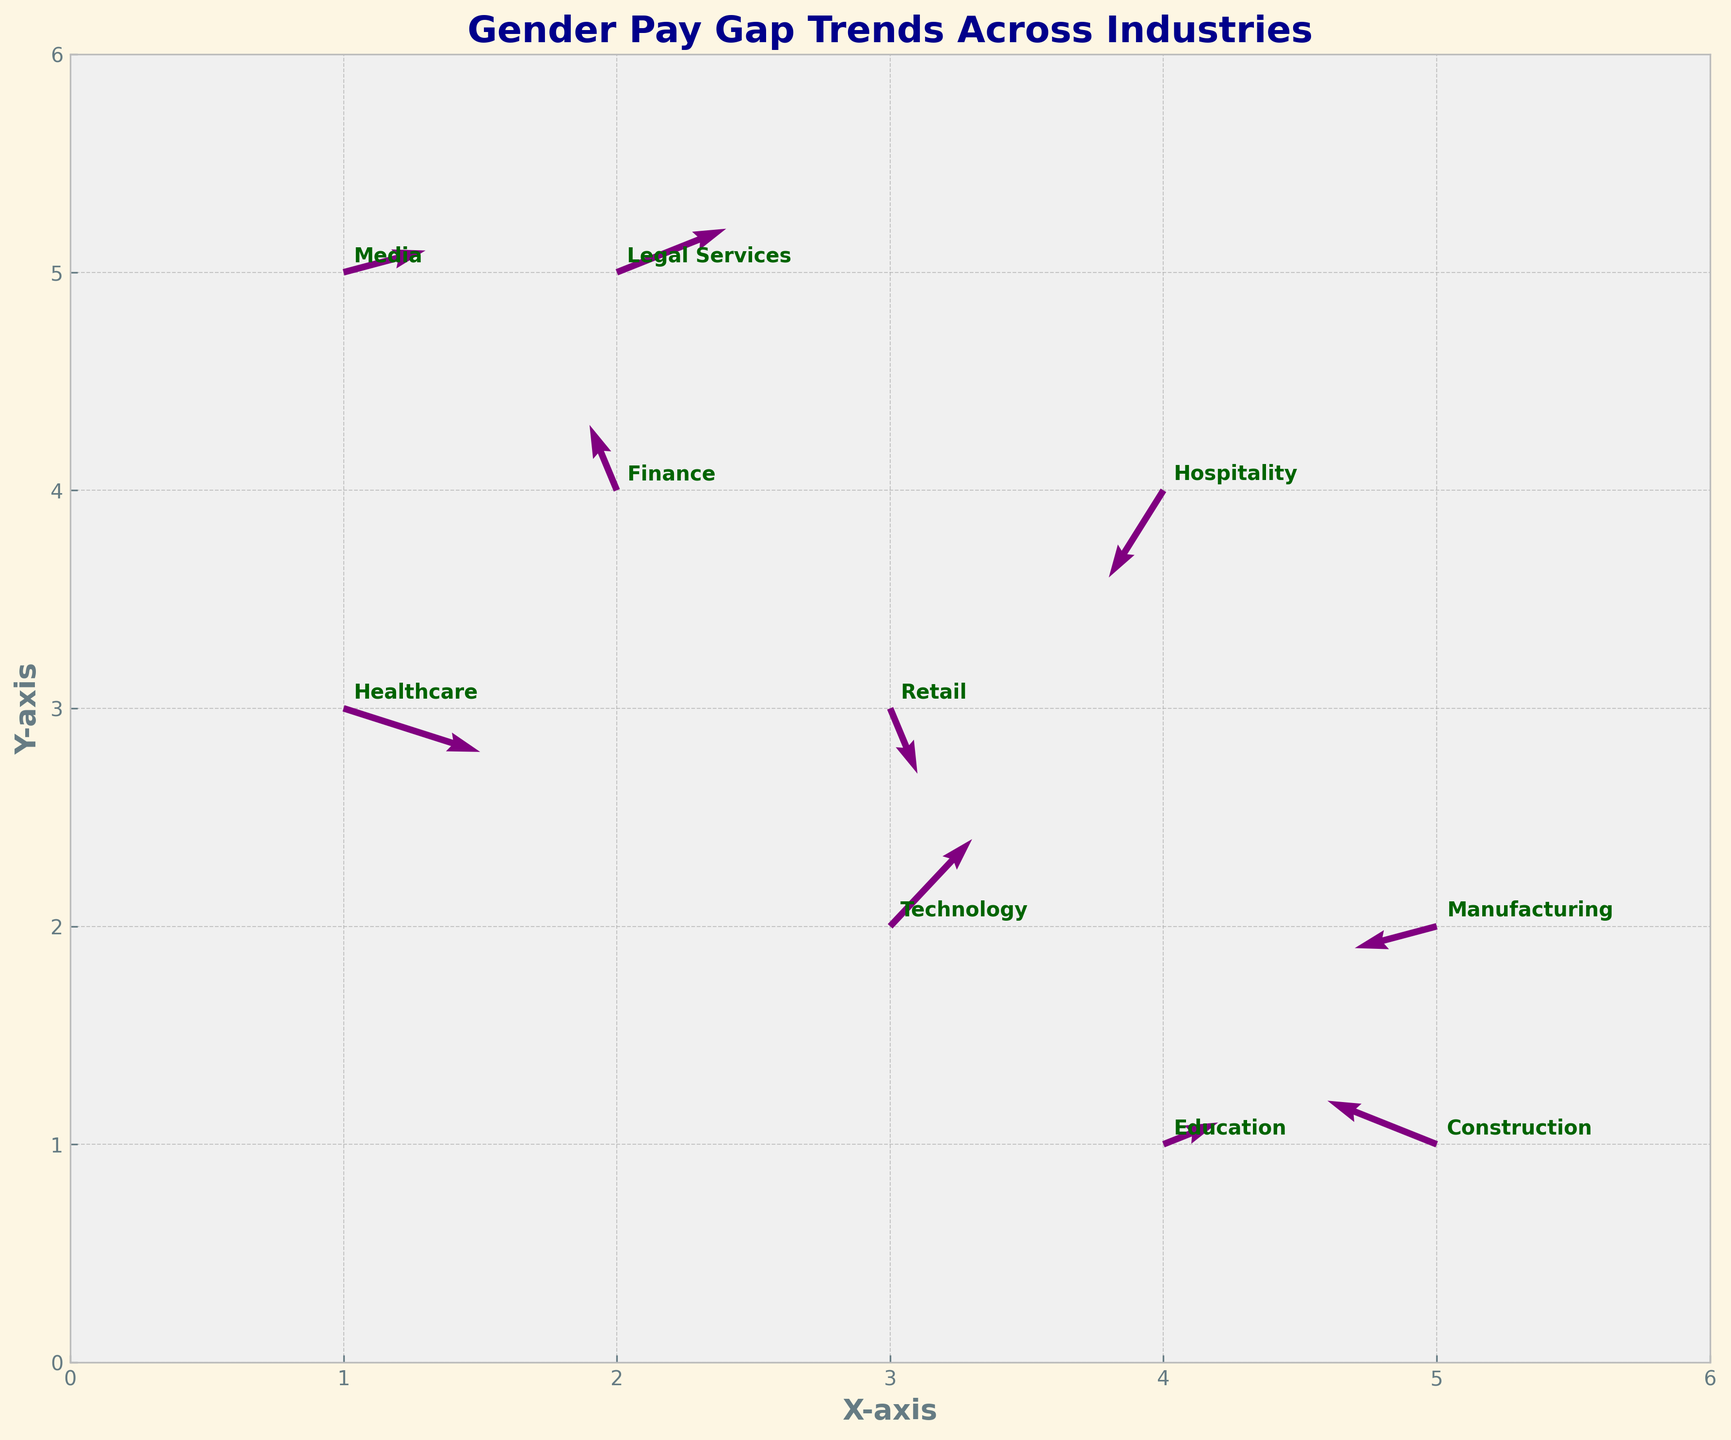What is the title of the plot? The title is shown at the top center of the plot in bold and dark blue color. It provides an overview of what the plot represents.
Answer: Gender Pay Gap Trends Across Industries How many industries are represented in the plot? Each industry is labeled next to a quiver arrow on the plot. By counting these labels, we determine the total number of industries depicted.
Answer: 10 Which industry has the largest horizontal arrow component? By observing the arrows, we notice their lengths and directions. The longest horizontal arrow points belong to Technology with a 0.03 value.
Answer: Technology What is the X and Y axis range labeled on the plot? The plot shows a range by checking the axis labels which extend from 0 to 6 on both the X and Y axes.
Answer: 0 to 6 Which industry shows a negative trend in both dimensions (U and V)? Examining the direction of arrows for industries that point downward and leftward, we see that Healthcare exhibits this trend.
Answer: Healthcare How do the trends for Technology and Retail industries compare? Technology shows a rising trend indicated by an upward-right arrow, while Retail shows a falling trend indicated by a downward arrow.
Answer: Technology is rising, Retail is falling What is the net directional trend in the Finance industry? The arrow for Finance points with U=-0.01 and V=0.03, forming a slightly downward-right trend. By looking at the arrow direction, we conclude a small positive vertical trend and a minor negative horizontal trend.
Answer: Slightly upward-right Which industry has the most upward trend? By examining the arrows pointing most steeply upward, we see that the Technology industry has the steepest upward trend with V=0.04.
Answer: Technology How are the Manufacturing and Construction industries similar in their directional trend? By comparing arrows for both industries, we note they both have negative horizontal components (U-values are negative) and minor positive/negative vertical trends.
Answer: Both have negative horizontal trends 